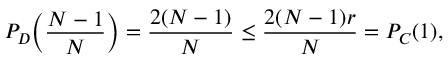Convert formula to latex. <formula><loc_0><loc_0><loc_500><loc_500>P _ { D } \left ( \frac { N - 1 } { N } \right ) = \frac { 2 ( N - 1 ) } { N } \leq \frac { 2 ( N - 1 ) r } { N } = P _ { C } ( 1 ) ,</formula> 